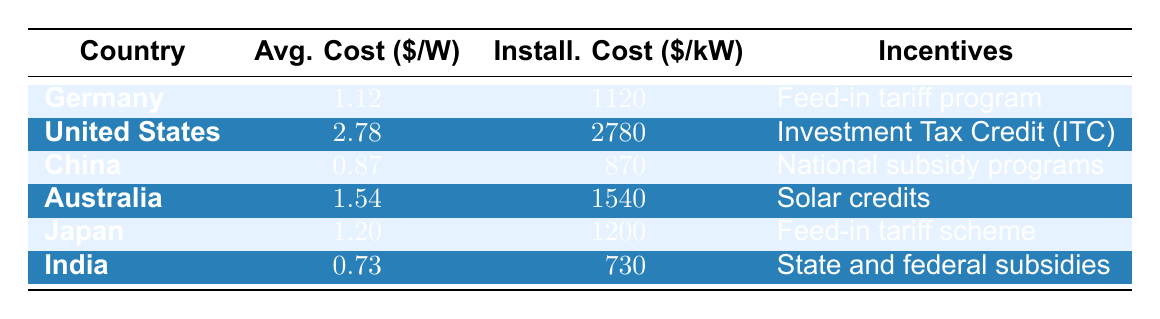What is the average installation cost per kilowatt in Germany? The table states that Germany has an installation cost of 1120 dollars per kilowatt. This is a direct retrieval from the corresponding row for Germany.
Answer: 1120 Which country has the highest average cost per watt? Looking through the average cost per watt values listed for each country, the United States has an average cost of 2.78 dollars per watt, which is higher than all the other countries in the table.
Answer: United States What is the total installation cost for Germany and Japan combined? To find the total installation cost for Germany and Japan, we add their installation costs: Germany (1120) + Japan (1200) = 2320 dollars per kilowatt.
Answer: 2320 Does China have the lowest installation cost per kilowatt among the listed countries? The installation cost per kilowatt for China is 870 dollars, which is less than the costs for Germany (1120), the United States (2780), Australia (1540), Japan (1200), and India (730). However, India has a lower cost. Thus, the statement is false.
Answer: No What percentage difference in installation cost per kilowatt exists between the United States and India? To find the percentage difference, we first calculate the difference: 2780 (United States) - 730 (India) = 2050 dollars. Then we find the average of both costs: (2780 + 730) / 2 = 1755. The percentage difference is (2050 / 1755) * 100 = 116.8%.
Answer: 116.8% 